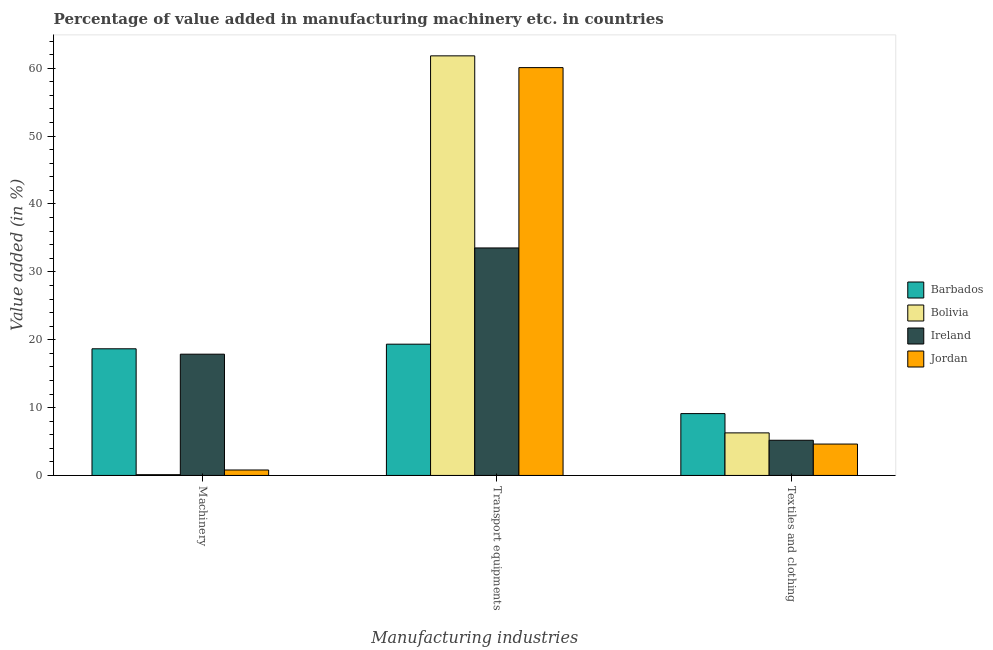How many different coloured bars are there?
Make the answer very short. 4. How many groups of bars are there?
Ensure brevity in your answer.  3. Are the number of bars per tick equal to the number of legend labels?
Your answer should be very brief. Yes. What is the label of the 2nd group of bars from the left?
Your answer should be very brief. Transport equipments. What is the value added in manufacturing transport equipments in Bolivia?
Keep it short and to the point. 61.83. Across all countries, what is the maximum value added in manufacturing machinery?
Ensure brevity in your answer.  18.66. Across all countries, what is the minimum value added in manufacturing machinery?
Provide a short and direct response. 0.11. In which country was the value added in manufacturing machinery maximum?
Your response must be concise. Barbados. In which country was the value added in manufacturing transport equipments minimum?
Provide a short and direct response. Barbados. What is the total value added in manufacturing transport equipments in the graph?
Make the answer very short. 174.79. What is the difference between the value added in manufacturing transport equipments in Jordan and that in Ireland?
Offer a very short reply. 26.57. What is the difference between the value added in manufacturing textile and clothing in Jordan and the value added in manufacturing transport equipments in Ireland?
Your answer should be very brief. -28.9. What is the average value added in manufacturing machinery per country?
Make the answer very short. 9.36. What is the difference between the value added in manufacturing transport equipments and value added in manufacturing machinery in Jordan?
Provide a short and direct response. 59.29. In how many countries, is the value added in manufacturing textile and clothing greater than 44 %?
Provide a succinct answer. 0. What is the ratio of the value added in manufacturing textile and clothing in Ireland to that in Jordan?
Keep it short and to the point. 1.12. What is the difference between the highest and the second highest value added in manufacturing transport equipments?
Your response must be concise. 1.73. What is the difference between the highest and the lowest value added in manufacturing transport equipments?
Ensure brevity in your answer.  42.49. Is the sum of the value added in manufacturing textile and clothing in Bolivia and Jordan greater than the maximum value added in manufacturing transport equipments across all countries?
Make the answer very short. No. What does the 4th bar from the right in Textiles and clothing represents?
Your response must be concise. Barbados. Is it the case that in every country, the sum of the value added in manufacturing machinery and value added in manufacturing transport equipments is greater than the value added in manufacturing textile and clothing?
Your answer should be compact. Yes. How many bars are there?
Make the answer very short. 12. Are all the bars in the graph horizontal?
Offer a very short reply. No. How many countries are there in the graph?
Provide a succinct answer. 4. Does the graph contain grids?
Give a very brief answer. No. How many legend labels are there?
Your answer should be very brief. 4. What is the title of the graph?
Provide a succinct answer. Percentage of value added in manufacturing machinery etc. in countries. Does "South Sudan" appear as one of the legend labels in the graph?
Provide a short and direct response. No. What is the label or title of the X-axis?
Offer a very short reply. Manufacturing industries. What is the label or title of the Y-axis?
Offer a very short reply. Value added (in %). What is the Value added (in %) of Barbados in Machinery?
Provide a succinct answer. 18.66. What is the Value added (in %) of Bolivia in Machinery?
Your answer should be very brief. 0.11. What is the Value added (in %) of Ireland in Machinery?
Ensure brevity in your answer.  17.87. What is the Value added (in %) in Jordan in Machinery?
Provide a succinct answer. 0.8. What is the Value added (in %) of Barbados in Transport equipments?
Ensure brevity in your answer.  19.34. What is the Value added (in %) of Bolivia in Transport equipments?
Give a very brief answer. 61.83. What is the Value added (in %) in Ireland in Transport equipments?
Provide a succinct answer. 33.52. What is the Value added (in %) in Jordan in Transport equipments?
Ensure brevity in your answer.  60.1. What is the Value added (in %) of Barbados in Textiles and clothing?
Ensure brevity in your answer.  9.11. What is the Value added (in %) in Bolivia in Textiles and clothing?
Give a very brief answer. 6.27. What is the Value added (in %) in Ireland in Textiles and clothing?
Offer a terse response. 5.18. What is the Value added (in %) of Jordan in Textiles and clothing?
Your response must be concise. 4.63. Across all Manufacturing industries, what is the maximum Value added (in %) of Barbados?
Offer a very short reply. 19.34. Across all Manufacturing industries, what is the maximum Value added (in %) in Bolivia?
Give a very brief answer. 61.83. Across all Manufacturing industries, what is the maximum Value added (in %) of Ireland?
Give a very brief answer. 33.52. Across all Manufacturing industries, what is the maximum Value added (in %) in Jordan?
Make the answer very short. 60.1. Across all Manufacturing industries, what is the minimum Value added (in %) of Barbados?
Your response must be concise. 9.11. Across all Manufacturing industries, what is the minimum Value added (in %) in Bolivia?
Provide a short and direct response. 0.11. Across all Manufacturing industries, what is the minimum Value added (in %) in Ireland?
Provide a succinct answer. 5.18. Across all Manufacturing industries, what is the minimum Value added (in %) of Jordan?
Keep it short and to the point. 0.8. What is the total Value added (in %) in Barbados in the graph?
Your answer should be very brief. 47.12. What is the total Value added (in %) of Bolivia in the graph?
Provide a succinct answer. 68.21. What is the total Value added (in %) in Ireland in the graph?
Make the answer very short. 56.58. What is the total Value added (in %) of Jordan in the graph?
Ensure brevity in your answer.  65.53. What is the difference between the Value added (in %) of Barbados in Machinery and that in Transport equipments?
Your answer should be very brief. -0.68. What is the difference between the Value added (in %) of Bolivia in Machinery and that in Transport equipments?
Keep it short and to the point. -61.72. What is the difference between the Value added (in %) in Ireland in Machinery and that in Transport equipments?
Ensure brevity in your answer.  -15.65. What is the difference between the Value added (in %) in Jordan in Machinery and that in Transport equipments?
Your response must be concise. -59.29. What is the difference between the Value added (in %) in Barbados in Machinery and that in Textiles and clothing?
Provide a succinct answer. 9.55. What is the difference between the Value added (in %) in Bolivia in Machinery and that in Textiles and clothing?
Give a very brief answer. -6.16. What is the difference between the Value added (in %) in Ireland in Machinery and that in Textiles and clothing?
Keep it short and to the point. 12.69. What is the difference between the Value added (in %) in Jordan in Machinery and that in Textiles and clothing?
Keep it short and to the point. -3.82. What is the difference between the Value added (in %) of Barbados in Transport equipments and that in Textiles and clothing?
Your response must be concise. 10.23. What is the difference between the Value added (in %) in Bolivia in Transport equipments and that in Textiles and clothing?
Your answer should be compact. 55.56. What is the difference between the Value added (in %) of Ireland in Transport equipments and that in Textiles and clothing?
Your response must be concise. 28.34. What is the difference between the Value added (in %) in Jordan in Transport equipments and that in Textiles and clothing?
Your answer should be compact. 55.47. What is the difference between the Value added (in %) of Barbados in Machinery and the Value added (in %) of Bolivia in Transport equipments?
Provide a short and direct response. -43.17. What is the difference between the Value added (in %) of Barbados in Machinery and the Value added (in %) of Ireland in Transport equipments?
Provide a succinct answer. -14.86. What is the difference between the Value added (in %) in Barbados in Machinery and the Value added (in %) in Jordan in Transport equipments?
Make the answer very short. -41.43. What is the difference between the Value added (in %) of Bolivia in Machinery and the Value added (in %) of Ireland in Transport equipments?
Keep it short and to the point. -33.41. What is the difference between the Value added (in %) of Bolivia in Machinery and the Value added (in %) of Jordan in Transport equipments?
Your response must be concise. -59.98. What is the difference between the Value added (in %) in Ireland in Machinery and the Value added (in %) in Jordan in Transport equipments?
Make the answer very short. -42.23. What is the difference between the Value added (in %) in Barbados in Machinery and the Value added (in %) in Bolivia in Textiles and clothing?
Make the answer very short. 12.39. What is the difference between the Value added (in %) of Barbados in Machinery and the Value added (in %) of Ireland in Textiles and clothing?
Provide a short and direct response. 13.48. What is the difference between the Value added (in %) in Barbados in Machinery and the Value added (in %) in Jordan in Textiles and clothing?
Ensure brevity in your answer.  14.04. What is the difference between the Value added (in %) in Bolivia in Machinery and the Value added (in %) in Ireland in Textiles and clothing?
Your answer should be compact. -5.07. What is the difference between the Value added (in %) of Bolivia in Machinery and the Value added (in %) of Jordan in Textiles and clothing?
Your response must be concise. -4.51. What is the difference between the Value added (in %) of Ireland in Machinery and the Value added (in %) of Jordan in Textiles and clothing?
Make the answer very short. 13.24. What is the difference between the Value added (in %) in Barbados in Transport equipments and the Value added (in %) in Bolivia in Textiles and clothing?
Ensure brevity in your answer.  13.07. What is the difference between the Value added (in %) of Barbados in Transport equipments and the Value added (in %) of Ireland in Textiles and clothing?
Ensure brevity in your answer.  14.16. What is the difference between the Value added (in %) in Barbados in Transport equipments and the Value added (in %) in Jordan in Textiles and clothing?
Make the answer very short. 14.72. What is the difference between the Value added (in %) in Bolivia in Transport equipments and the Value added (in %) in Ireland in Textiles and clothing?
Your answer should be compact. 56.65. What is the difference between the Value added (in %) in Bolivia in Transport equipments and the Value added (in %) in Jordan in Textiles and clothing?
Your answer should be very brief. 57.2. What is the difference between the Value added (in %) of Ireland in Transport equipments and the Value added (in %) of Jordan in Textiles and clothing?
Provide a succinct answer. 28.9. What is the average Value added (in %) of Barbados per Manufacturing industries?
Provide a short and direct response. 15.71. What is the average Value added (in %) in Bolivia per Manufacturing industries?
Your answer should be very brief. 22.74. What is the average Value added (in %) in Ireland per Manufacturing industries?
Provide a succinct answer. 18.86. What is the average Value added (in %) in Jordan per Manufacturing industries?
Provide a short and direct response. 21.84. What is the difference between the Value added (in %) in Barbados and Value added (in %) in Bolivia in Machinery?
Your answer should be compact. 18.55. What is the difference between the Value added (in %) of Barbados and Value added (in %) of Ireland in Machinery?
Provide a succinct answer. 0.79. What is the difference between the Value added (in %) in Barbados and Value added (in %) in Jordan in Machinery?
Make the answer very short. 17.86. What is the difference between the Value added (in %) in Bolivia and Value added (in %) in Ireland in Machinery?
Offer a terse response. -17.76. What is the difference between the Value added (in %) in Bolivia and Value added (in %) in Jordan in Machinery?
Your answer should be very brief. -0.69. What is the difference between the Value added (in %) in Ireland and Value added (in %) in Jordan in Machinery?
Offer a very short reply. 17.07. What is the difference between the Value added (in %) in Barbados and Value added (in %) in Bolivia in Transport equipments?
Offer a terse response. -42.49. What is the difference between the Value added (in %) in Barbados and Value added (in %) in Ireland in Transport equipments?
Provide a succinct answer. -14.18. What is the difference between the Value added (in %) of Barbados and Value added (in %) of Jordan in Transport equipments?
Offer a very short reply. -40.75. What is the difference between the Value added (in %) of Bolivia and Value added (in %) of Ireland in Transport equipments?
Make the answer very short. 28.31. What is the difference between the Value added (in %) of Bolivia and Value added (in %) of Jordan in Transport equipments?
Keep it short and to the point. 1.73. What is the difference between the Value added (in %) of Ireland and Value added (in %) of Jordan in Transport equipments?
Offer a very short reply. -26.57. What is the difference between the Value added (in %) of Barbados and Value added (in %) of Bolivia in Textiles and clothing?
Offer a very short reply. 2.84. What is the difference between the Value added (in %) in Barbados and Value added (in %) in Ireland in Textiles and clothing?
Make the answer very short. 3.93. What is the difference between the Value added (in %) in Barbados and Value added (in %) in Jordan in Textiles and clothing?
Give a very brief answer. 4.49. What is the difference between the Value added (in %) in Bolivia and Value added (in %) in Ireland in Textiles and clothing?
Provide a succinct answer. 1.09. What is the difference between the Value added (in %) in Bolivia and Value added (in %) in Jordan in Textiles and clothing?
Offer a terse response. 1.65. What is the difference between the Value added (in %) in Ireland and Value added (in %) in Jordan in Textiles and clothing?
Offer a very short reply. 0.56. What is the ratio of the Value added (in %) in Barbados in Machinery to that in Transport equipments?
Provide a succinct answer. 0.96. What is the ratio of the Value added (in %) in Bolivia in Machinery to that in Transport equipments?
Ensure brevity in your answer.  0. What is the ratio of the Value added (in %) in Ireland in Machinery to that in Transport equipments?
Your answer should be compact. 0.53. What is the ratio of the Value added (in %) in Jordan in Machinery to that in Transport equipments?
Your answer should be very brief. 0.01. What is the ratio of the Value added (in %) of Barbados in Machinery to that in Textiles and clothing?
Ensure brevity in your answer.  2.05. What is the ratio of the Value added (in %) in Bolivia in Machinery to that in Textiles and clothing?
Your answer should be very brief. 0.02. What is the ratio of the Value added (in %) of Ireland in Machinery to that in Textiles and clothing?
Make the answer very short. 3.45. What is the ratio of the Value added (in %) in Jordan in Machinery to that in Textiles and clothing?
Offer a terse response. 0.17. What is the ratio of the Value added (in %) in Barbados in Transport equipments to that in Textiles and clothing?
Your answer should be compact. 2.12. What is the ratio of the Value added (in %) in Bolivia in Transport equipments to that in Textiles and clothing?
Offer a terse response. 9.86. What is the ratio of the Value added (in %) of Ireland in Transport equipments to that in Textiles and clothing?
Offer a terse response. 6.47. What is the ratio of the Value added (in %) of Jordan in Transport equipments to that in Textiles and clothing?
Your answer should be compact. 12.99. What is the difference between the highest and the second highest Value added (in %) in Barbados?
Offer a very short reply. 0.68. What is the difference between the highest and the second highest Value added (in %) in Bolivia?
Offer a very short reply. 55.56. What is the difference between the highest and the second highest Value added (in %) in Ireland?
Make the answer very short. 15.65. What is the difference between the highest and the second highest Value added (in %) in Jordan?
Ensure brevity in your answer.  55.47. What is the difference between the highest and the lowest Value added (in %) of Barbados?
Ensure brevity in your answer.  10.23. What is the difference between the highest and the lowest Value added (in %) of Bolivia?
Ensure brevity in your answer.  61.72. What is the difference between the highest and the lowest Value added (in %) in Ireland?
Keep it short and to the point. 28.34. What is the difference between the highest and the lowest Value added (in %) of Jordan?
Your answer should be very brief. 59.29. 